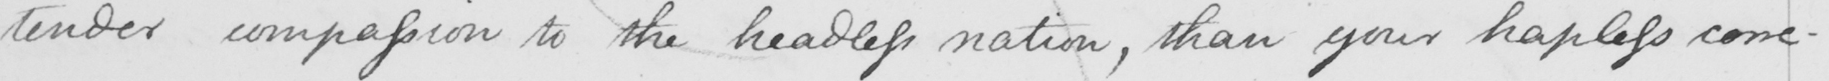Transcribe the text shown in this historical manuscript line. tender compassion to the headless nation , than your hapless corre- 